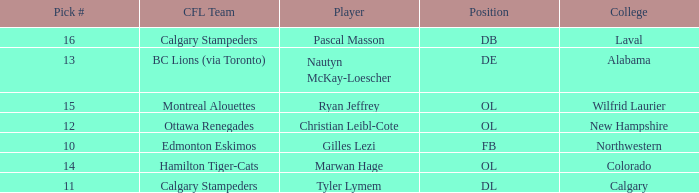Which player from the 2004 CFL draft attended Wilfrid Laurier? Ryan Jeffrey. 